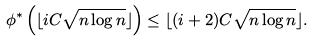Convert formula to latex. <formula><loc_0><loc_0><loc_500><loc_500>\phi ^ { * } \left ( \lfloor i C \sqrt { n \log n } \rfloor \right ) \leq \lfloor ( i + 2 ) C \sqrt { n \log n } \rfloor .</formula> 